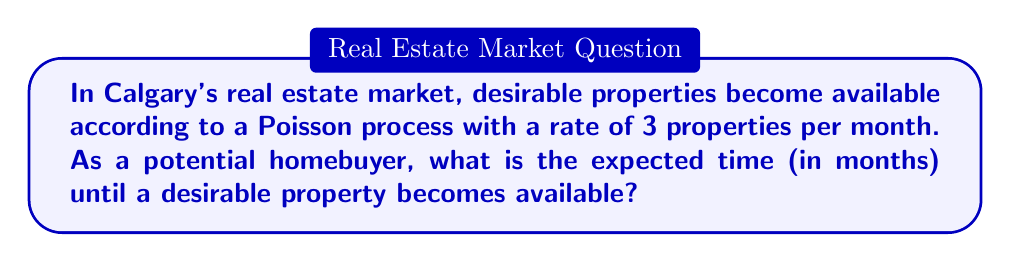Show me your answer to this math problem. To solve this problem, we'll use the properties of the Poisson process:

1) In a Poisson process, the time between events (in this case, desirable properties becoming available) follows an exponential distribution.

2) The rate parameter of the Poisson process, λ, is given as 3 properties per month.

3) For an exponential distribution, the expected value (mean) is the inverse of the rate parameter.

4) The formula for the expected value of an exponential distribution is:

   $$ E[X] = \frac{1}{\lambda} $$

   where X is the random variable representing the time until the next event, and λ is the rate parameter.

5) Substituting our given rate:

   $$ E[X] = \frac{1}{3} $$

6) This gives us the expected time in months.

Therefore, the expected time until a desirable property becomes available is 1/3 of a month.
Answer: $\frac{1}{3}$ months 